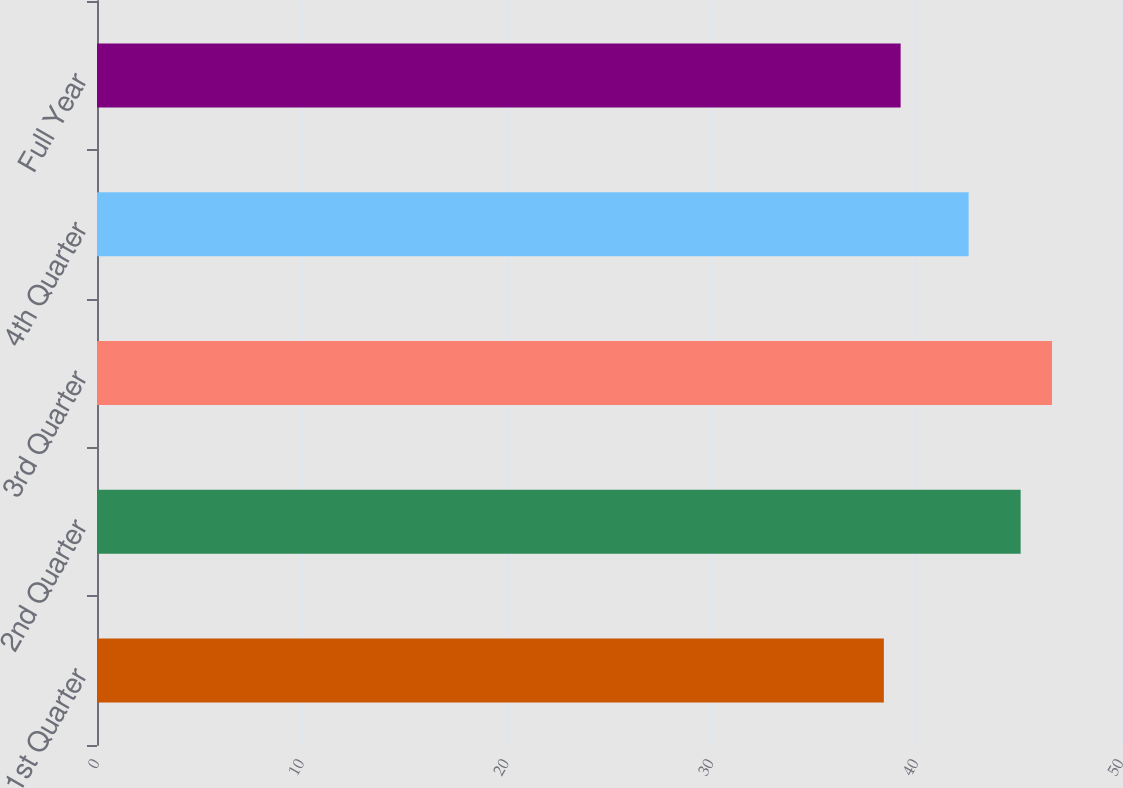Convert chart. <chart><loc_0><loc_0><loc_500><loc_500><bar_chart><fcel>1st Quarter<fcel>2nd Quarter<fcel>3rd Quarter<fcel>4th Quarter<fcel>Full Year<nl><fcel>38.42<fcel>45.1<fcel>46.63<fcel>42.56<fcel>39.24<nl></chart> 